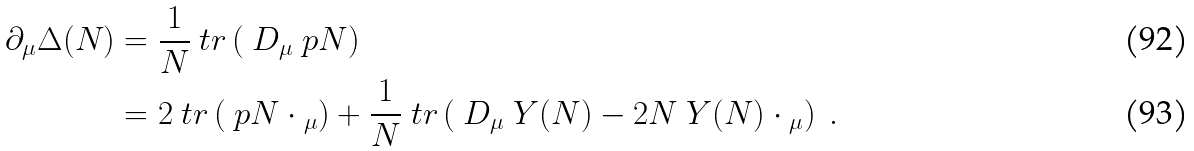<formula> <loc_0><loc_0><loc_500><loc_500>\partial _ { \mu } \Delta ( N ) & = \frac { 1 } { N } \ t r \left ( \ D _ { \mu } \ p { N } \right ) \\ & = 2 \ t r \left ( \ p { N } \cdot \L _ { \mu } \right ) + \frac { 1 } { N } \ t r \left ( \ D _ { \mu } \ Y ( N ) - 2 N \ Y ( N ) \cdot \L _ { \mu } \right ) \ .</formula> 